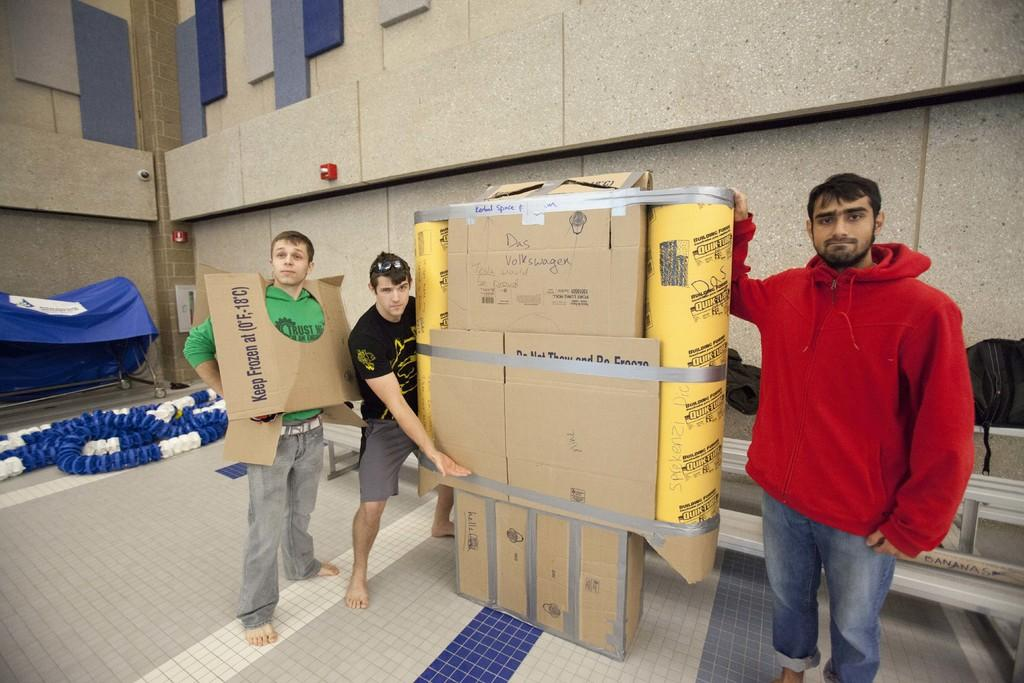<image>
Render a clear and concise summary of the photo. The men hold something that they have built using quik tubes at each side. 